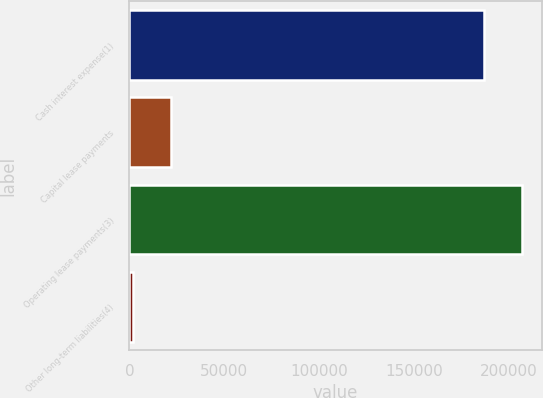<chart> <loc_0><loc_0><loc_500><loc_500><bar_chart><fcel>Cash interest expense(1)<fcel>Capital lease payments<fcel>Operating lease payments(3)<fcel>Other long-term liabilities(4)<nl><fcel>187000<fcel>21888<fcel>207036<fcel>1852<nl></chart> 